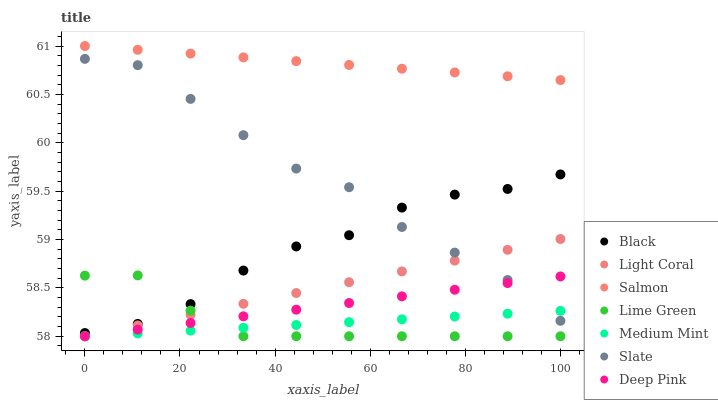Does Medium Mint have the minimum area under the curve?
Answer yes or no. Yes. Does Salmon have the maximum area under the curve?
Answer yes or no. Yes. Does Deep Pink have the minimum area under the curve?
Answer yes or no. No. Does Deep Pink have the maximum area under the curve?
Answer yes or no. No. Is Medium Mint the smoothest?
Answer yes or no. Yes. Is Slate the roughest?
Answer yes or no. Yes. Is Deep Pink the smoothest?
Answer yes or no. No. Is Deep Pink the roughest?
Answer yes or no. No. Does Medium Mint have the lowest value?
Answer yes or no. Yes. Does Slate have the lowest value?
Answer yes or no. No. Does Salmon have the highest value?
Answer yes or no. Yes. Does Deep Pink have the highest value?
Answer yes or no. No. Is Slate less than Salmon?
Answer yes or no. Yes. Is Black greater than Deep Pink?
Answer yes or no. Yes. Does Deep Pink intersect Medium Mint?
Answer yes or no. Yes. Is Deep Pink less than Medium Mint?
Answer yes or no. No. Is Deep Pink greater than Medium Mint?
Answer yes or no. No. Does Slate intersect Salmon?
Answer yes or no. No. 